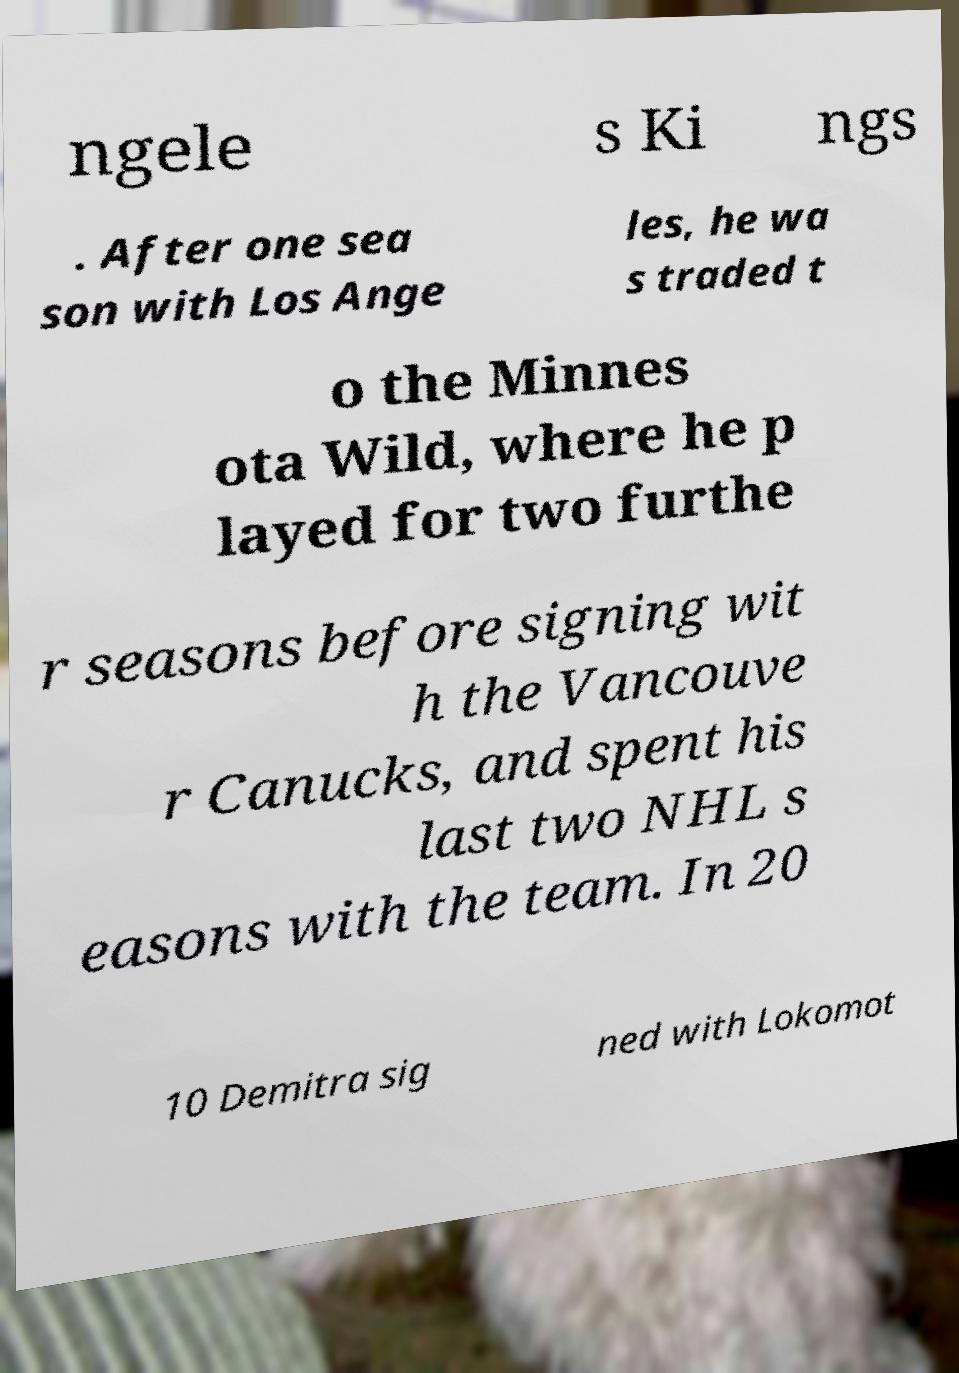Can you accurately transcribe the text from the provided image for me? ngele s Ki ngs . After one sea son with Los Ange les, he wa s traded t o the Minnes ota Wild, where he p layed for two furthe r seasons before signing wit h the Vancouve r Canucks, and spent his last two NHL s easons with the team. In 20 10 Demitra sig ned with Lokomot 